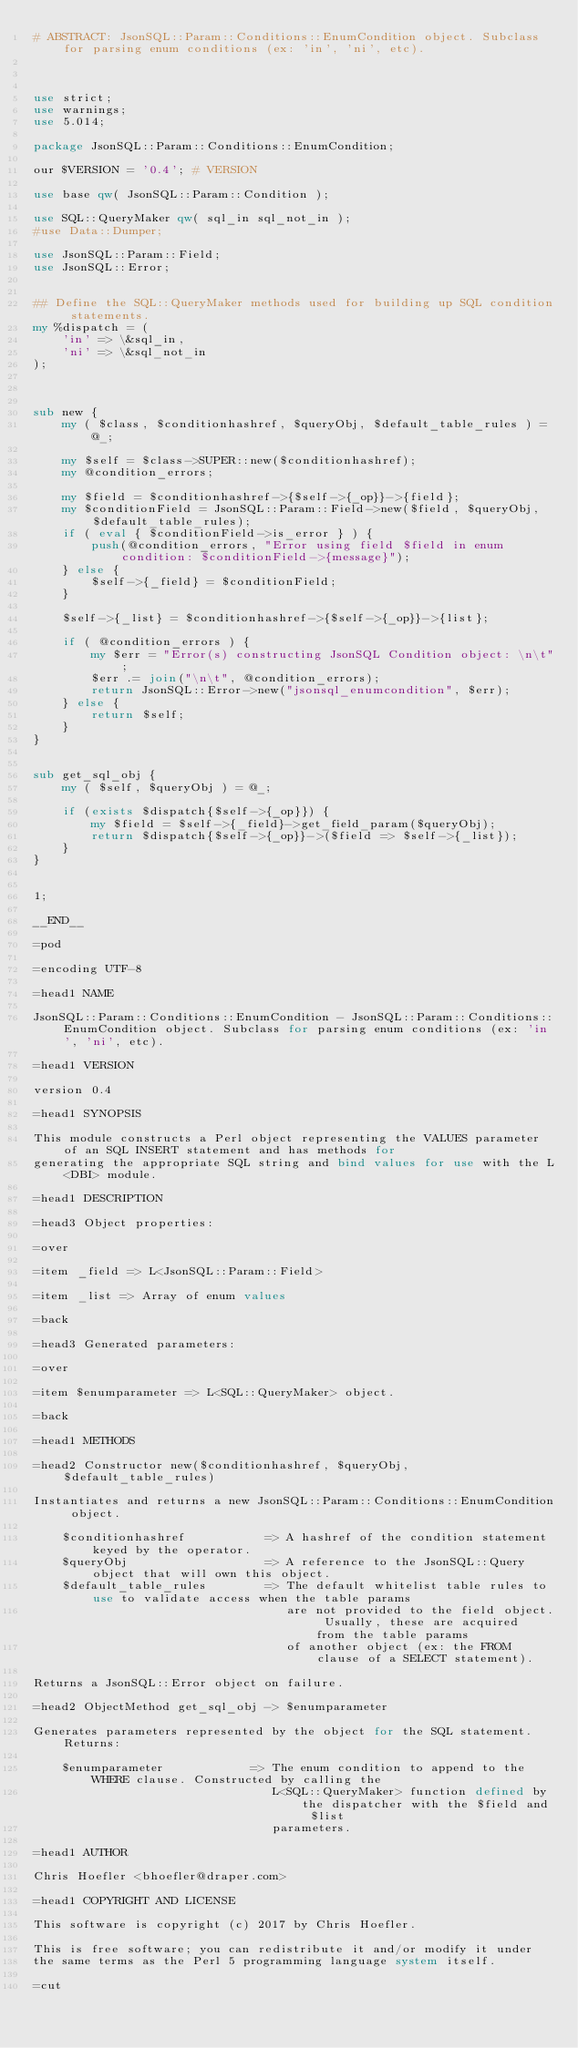Convert code to text. <code><loc_0><loc_0><loc_500><loc_500><_Perl_># ABSTRACT: JsonSQL::Param::Conditions::EnumCondition object. Subclass for parsing enum conditions (ex: 'in', 'ni', etc).



use strict;
use warnings;
use 5.014;

package JsonSQL::Param::Conditions::EnumCondition;

our $VERSION = '0.4'; # VERSION

use base qw( JsonSQL::Param::Condition );

use SQL::QueryMaker qw( sql_in sql_not_in );
#use Data::Dumper;

use JsonSQL::Param::Field;
use JsonSQL::Error;


## Define the SQL::QueryMaker methods used for building up SQL condition statements.
my %dispatch = (
    'in' => \&sql_in,
    'ni' => \&sql_not_in
);



sub new {
    my ( $class, $conditionhashref, $queryObj, $default_table_rules ) = @_;
    
    my $self = $class->SUPER::new($conditionhashref);
    my @condition_errors;
    
    my $field = $conditionhashref->{$self->{_op}}->{field};
    my $conditionField = JsonSQL::Param::Field->new($field, $queryObj, $default_table_rules);
    if ( eval { $conditionField->is_error } ) {
        push(@condition_errors, "Error using field $field in enum condition: $conditionField->{message}");
    } else {
        $self->{_field} = $conditionField;
    }
    
    $self->{_list} = $conditionhashref->{$self->{_op}}->{list};
    
    if ( @condition_errors ) {
        my $err = "Error(s) constructing JsonSQL Condition object: \n\t";
        $err .= join("\n\t", @condition_errors);
        return JsonSQL::Error->new("jsonsql_enumcondition", $err);
    } else {
        return $self;
    }
}


sub get_sql_obj {
    my ( $self, $queryObj ) = @_;
    
    if (exists $dispatch{$self->{_op}}) {
        my $field = $self->{_field}->get_field_param($queryObj);
        return $dispatch{$self->{_op}}->($field => $self->{_list});
    }
}


1;

__END__

=pod

=encoding UTF-8

=head1 NAME

JsonSQL::Param::Conditions::EnumCondition - JsonSQL::Param::Conditions::EnumCondition object. Subclass for parsing enum conditions (ex: 'in', 'ni', etc).

=head1 VERSION

version 0.4

=head1 SYNOPSIS

This module constructs a Perl object representing the VALUES parameter of an SQL INSERT statement and has methods for 
generating the appropriate SQL string and bind values for use with the L<DBI> module.

=head1 DESCRIPTION

=head3 Object properties:

=over

=item _field => L<JsonSQL::Param::Field>

=item _list => Array of enum values

=back

=head3 Generated parameters:

=over

=item $enumparameter => L<SQL::QueryMaker> object.

=back

=head1 METHODS

=head2 Constructor new($conditionhashref, $queryObj, $default_table_rules)

Instantiates and returns a new JsonSQL::Param::Conditions::EnumCondition object.

    $conditionhashref           => A hashref of the condition statement keyed by the operator.
    $queryObj                   => A reference to the JsonSQL::Query object that will own this object.
    $default_table_rules        => The default whitelist table rules to use to validate access when the table params 
                                   are not provided to the field object. Usually, these are acquired from the table params
                                   of another object (ex: the FROM clause of a SELECT statement).

Returns a JsonSQL::Error object on failure.

=head2 ObjectMethod get_sql_obj -> $enumparameter

Generates parameters represented by the object for the SQL statement. Returns:

    $enumparameter            => The enum condition to append to the WHERE clause. Constructed by calling the 
                                 L<SQL::QueryMaker> function defined by the dispatcher with the $field and $list
                                 parameters.

=head1 AUTHOR

Chris Hoefler <bhoefler@draper.com>

=head1 COPYRIGHT AND LICENSE

This software is copyright (c) 2017 by Chris Hoefler.

This is free software; you can redistribute it and/or modify it under
the same terms as the Perl 5 programming language system itself.

=cut
</code> 